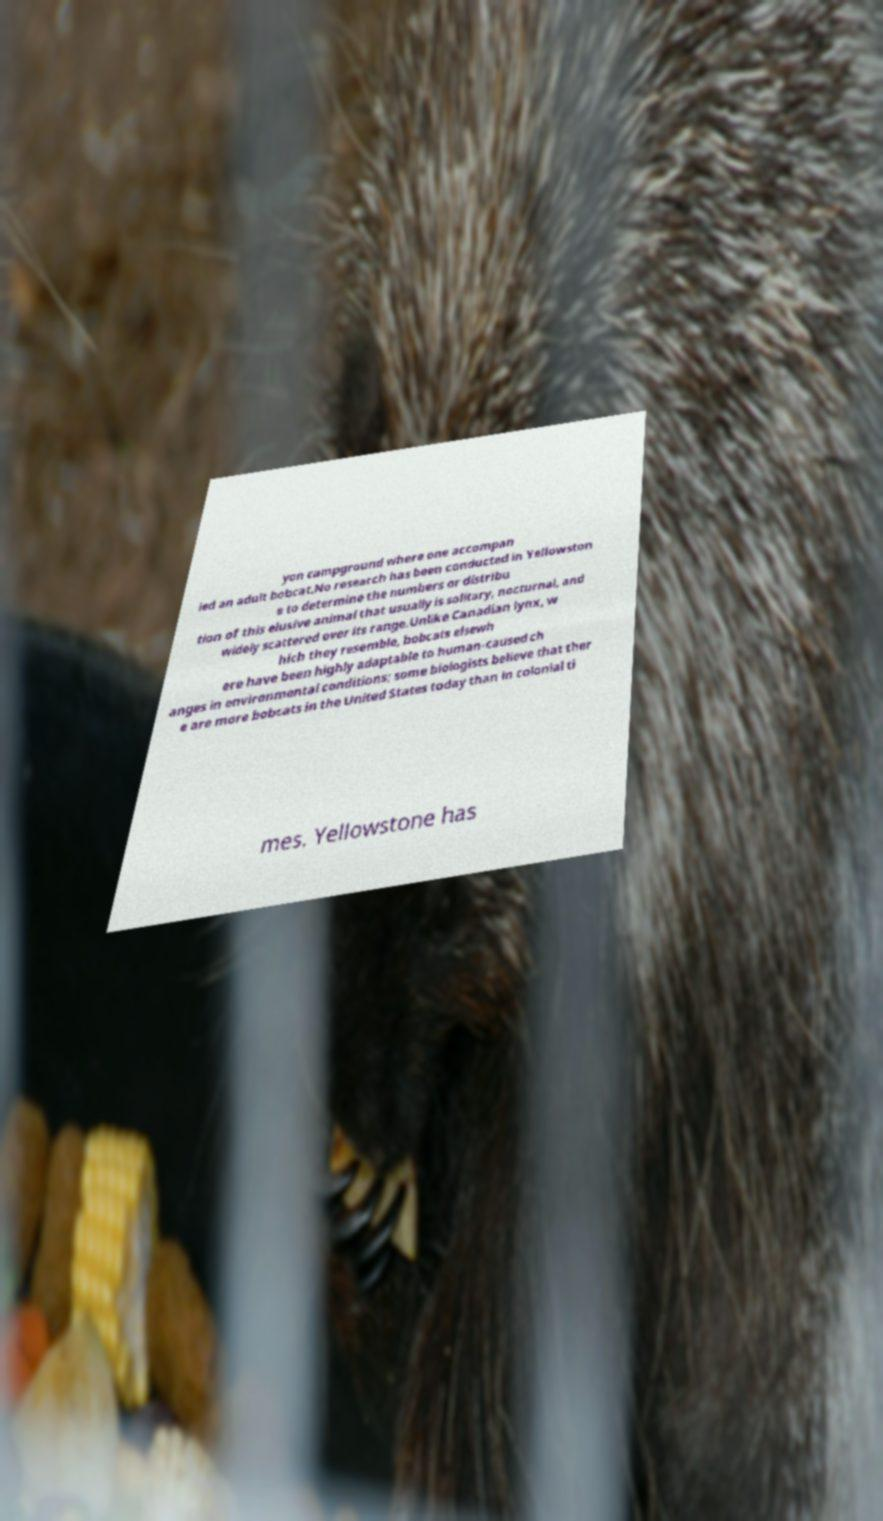Please read and relay the text visible in this image. What does it say? yon campground where one accompan ied an adult bobcat.No research has been conducted in Yellowston e to determine the numbers or distribu tion of this elusive animal that usually is solitary, nocturnal, and widely scattered over its range.Unlike Canadian lynx, w hich they resemble, bobcats elsewh ere have been highly adaptable to human-caused ch anges in environmental conditions; some biologists believe that ther e are more bobcats in the United States today than in colonial ti mes. Yellowstone has 